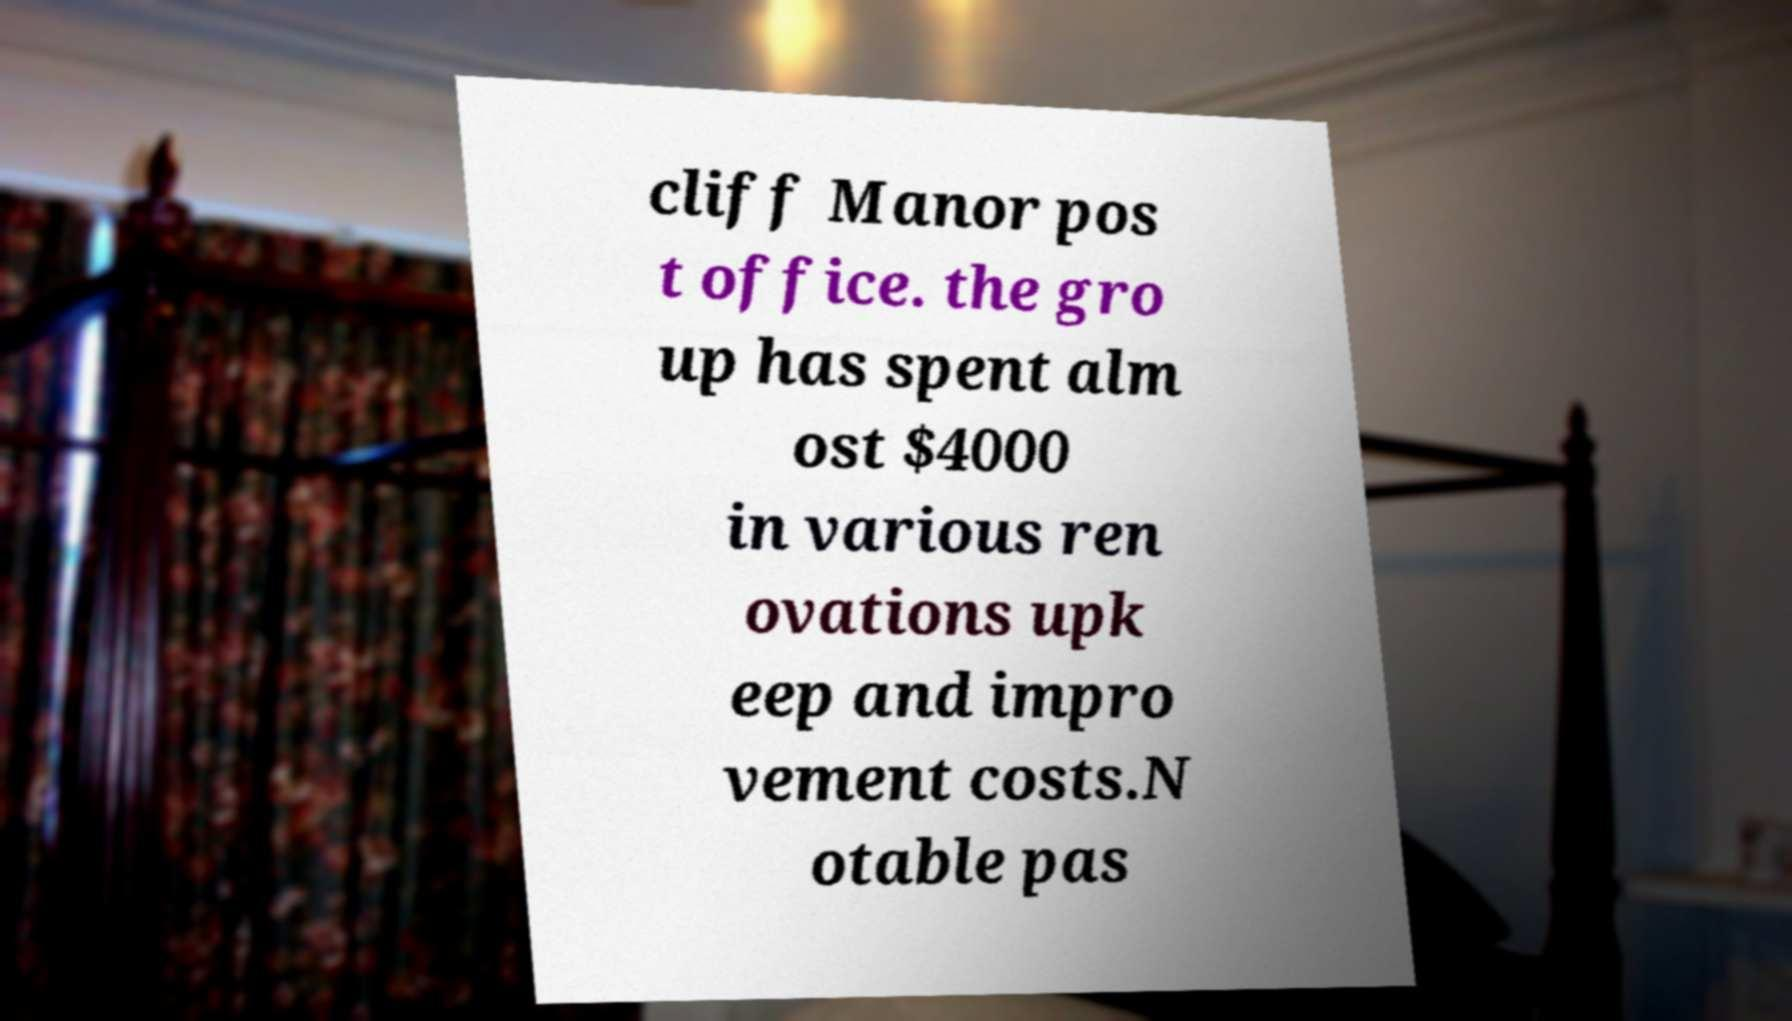Please identify and transcribe the text found in this image. cliff Manor pos t office. the gro up has spent alm ost $4000 in various ren ovations upk eep and impro vement costs.N otable pas 